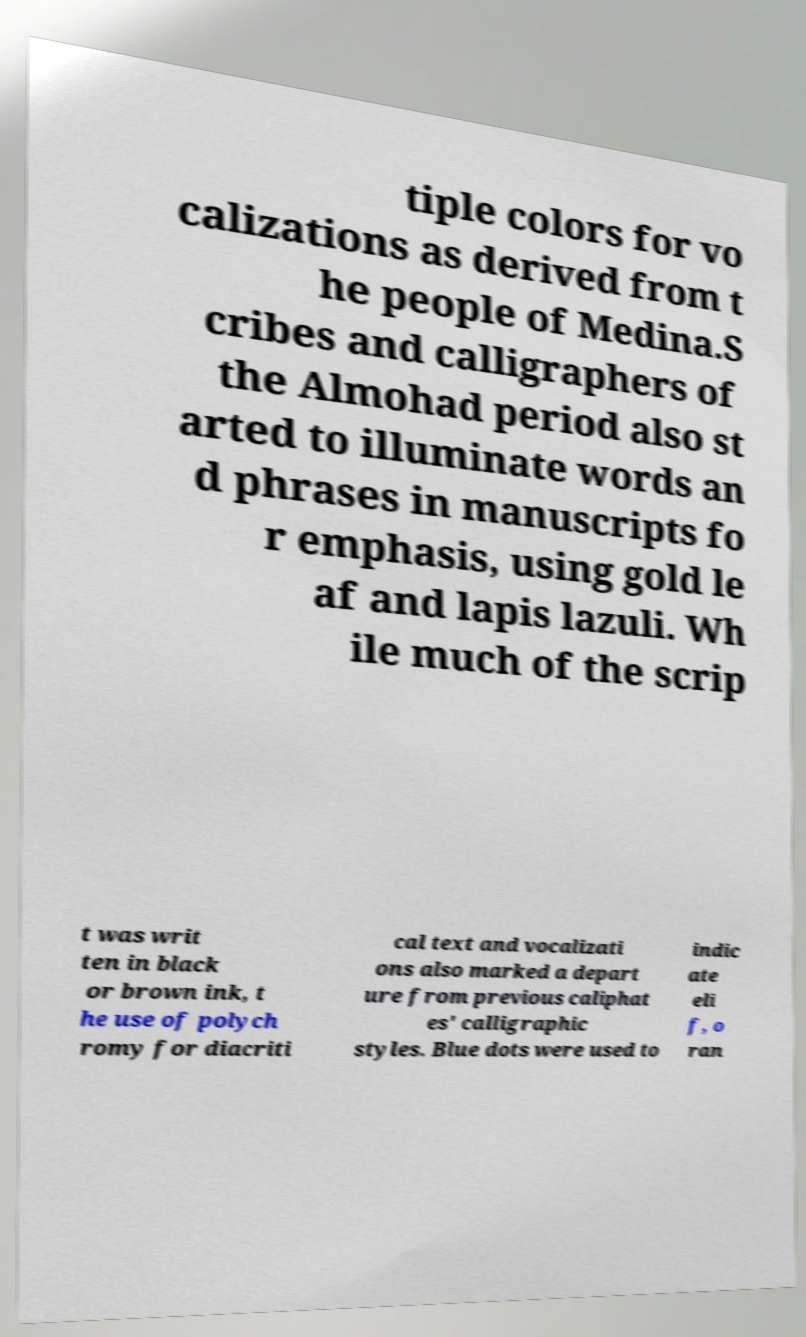What messages or text are displayed in this image? I need them in a readable, typed format. tiple colors for vo calizations as derived from t he people of Medina.S cribes and calligraphers of the Almohad period also st arted to illuminate words an d phrases in manuscripts fo r emphasis, using gold le af and lapis lazuli. Wh ile much of the scrip t was writ ten in black or brown ink, t he use of polych romy for diacriti cal text and vocalizati ons also marked a depart ure from previous caliphat es' calligraphic styles. Blue dots were used to indic ate eli f, o ran 